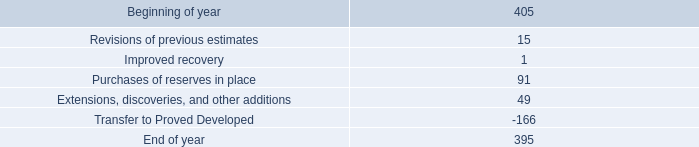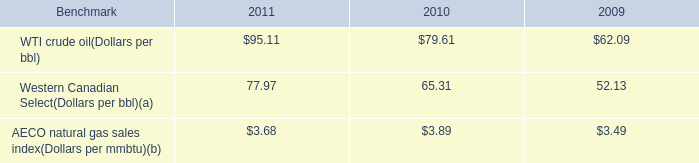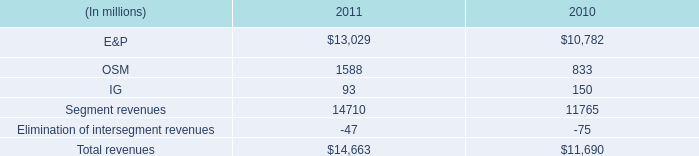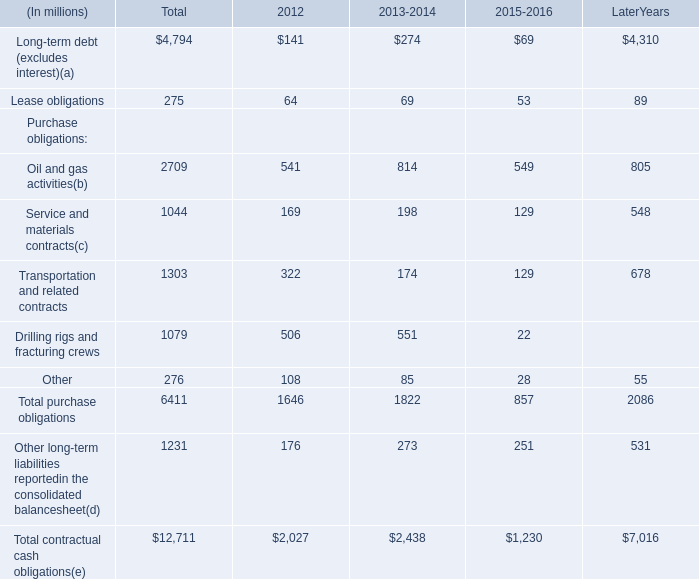How many kinds of Purchase obligations are more than 500 million in 2012? 
Answer: 2. 